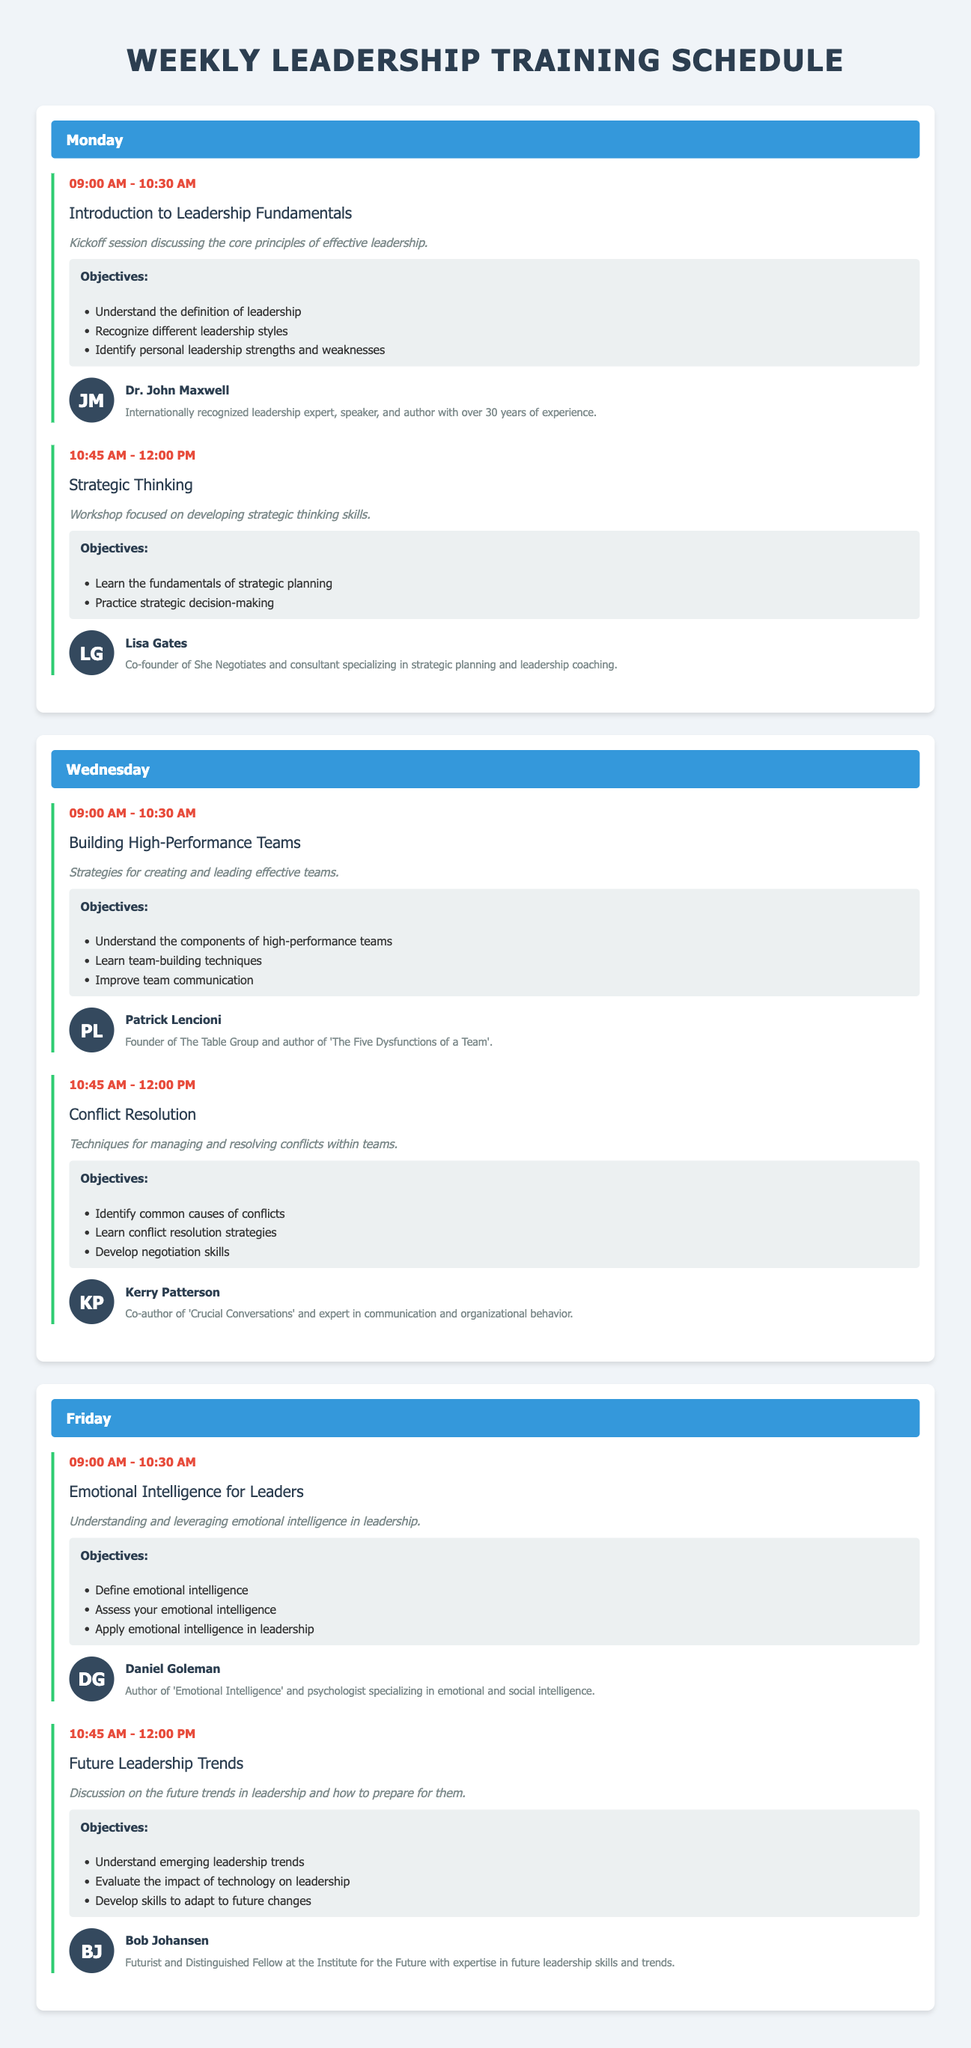what is the title of the itinerary? The title of the itinerary is prominently displayed at the top of the document.
Answer: Weekly Leadership Training Schedule who is the speaker for the "Introduction to Leadership Fundamentals" session? Each session lists a speaker, and this one is the first session of the week.
Answer: Dr. John Maxwell what time does the "Emotional Intelligence for Leaders" session start? The schedule includes specific times for each session, and this session is listed on Friday.
Answer: 09:00 AM how many objectives are listed for the "Conflict Resolution" session? Each session has a list of objectives, and this question refers to the number under the listed session.
Answer: Three which day features the "Building High-Performance Teams" workshop? The day of each session is detailed in the itinerary, and this one is not on the Monday sessions.
Answer: Wednesday who is the speaker for the "Future Leadership Trends" session? Each session mentions the speaker's name, particularly in the overview of the Friday agenda.
Answer: Bob Johansen what is the focus of the "Strategic Thinking" workshop? The workshop description indicates the broader topic it addresses, crucial to strategic development.
Answer: Developing strategic thinking skills how long is each session scheduled to last? The document consistently lists the start and end times of each session, allowing for a straightforward duration calculation.
Answer: 1 hour and 30 minutes what type of session is held at 10:45 AM on Wednesday? The timetable provides information about the session types based on the given times on Wednesday.
Answer: Conflict Resolution 